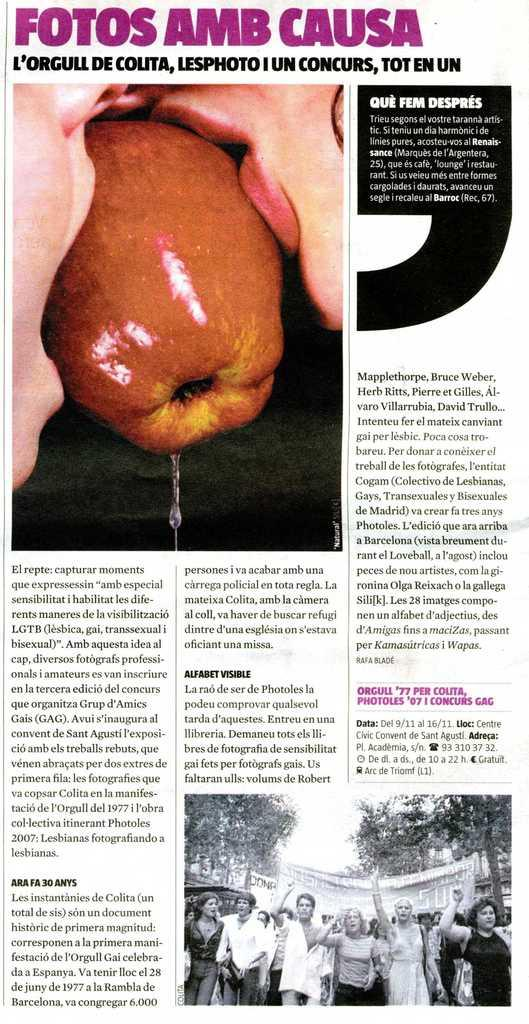<image>
Offer a succinct explanation of the picture presented. News article that has Fotos Amb Causa as the headline in purple. 